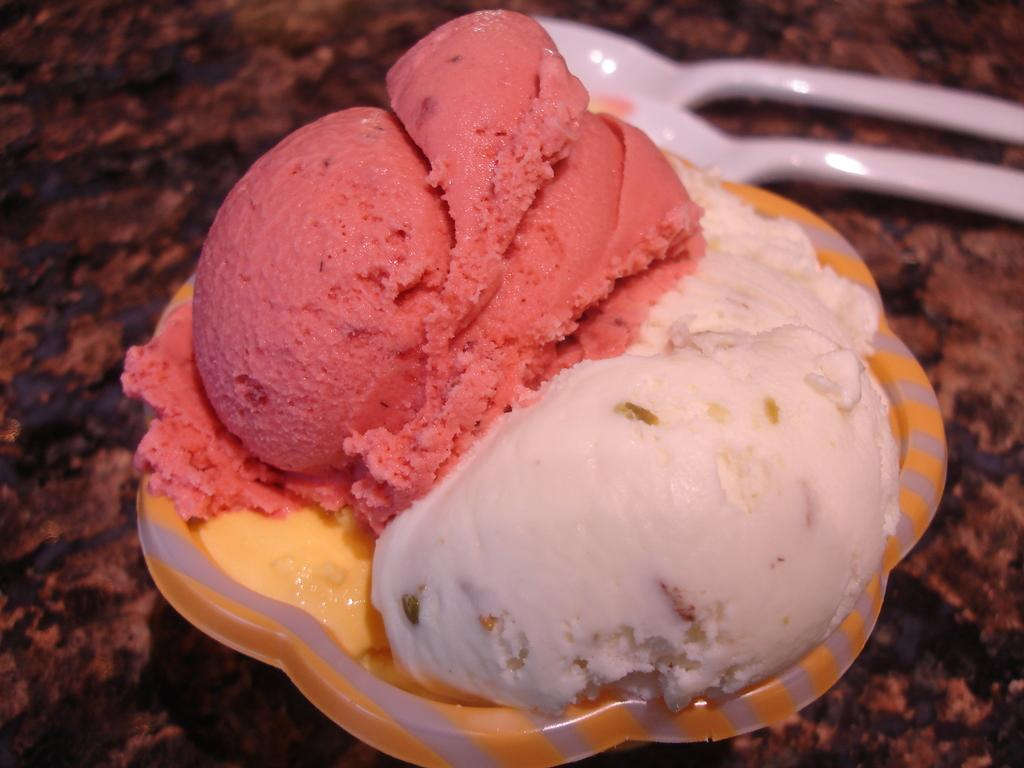What is the main piece of furniture in the image? There is a table in the image. What is placed on the table? There is a bowl on the table. What is inside the bowl? The bowl contains ice cream. What type of utensils are on the table? There are white-colored spoons on the table. Are there any shoes visible in the image? No, there are no shoes visible in the image. Is there a volcano erupting in the background of the image? No, there is no volcano or any indication of an eruption in the image. 